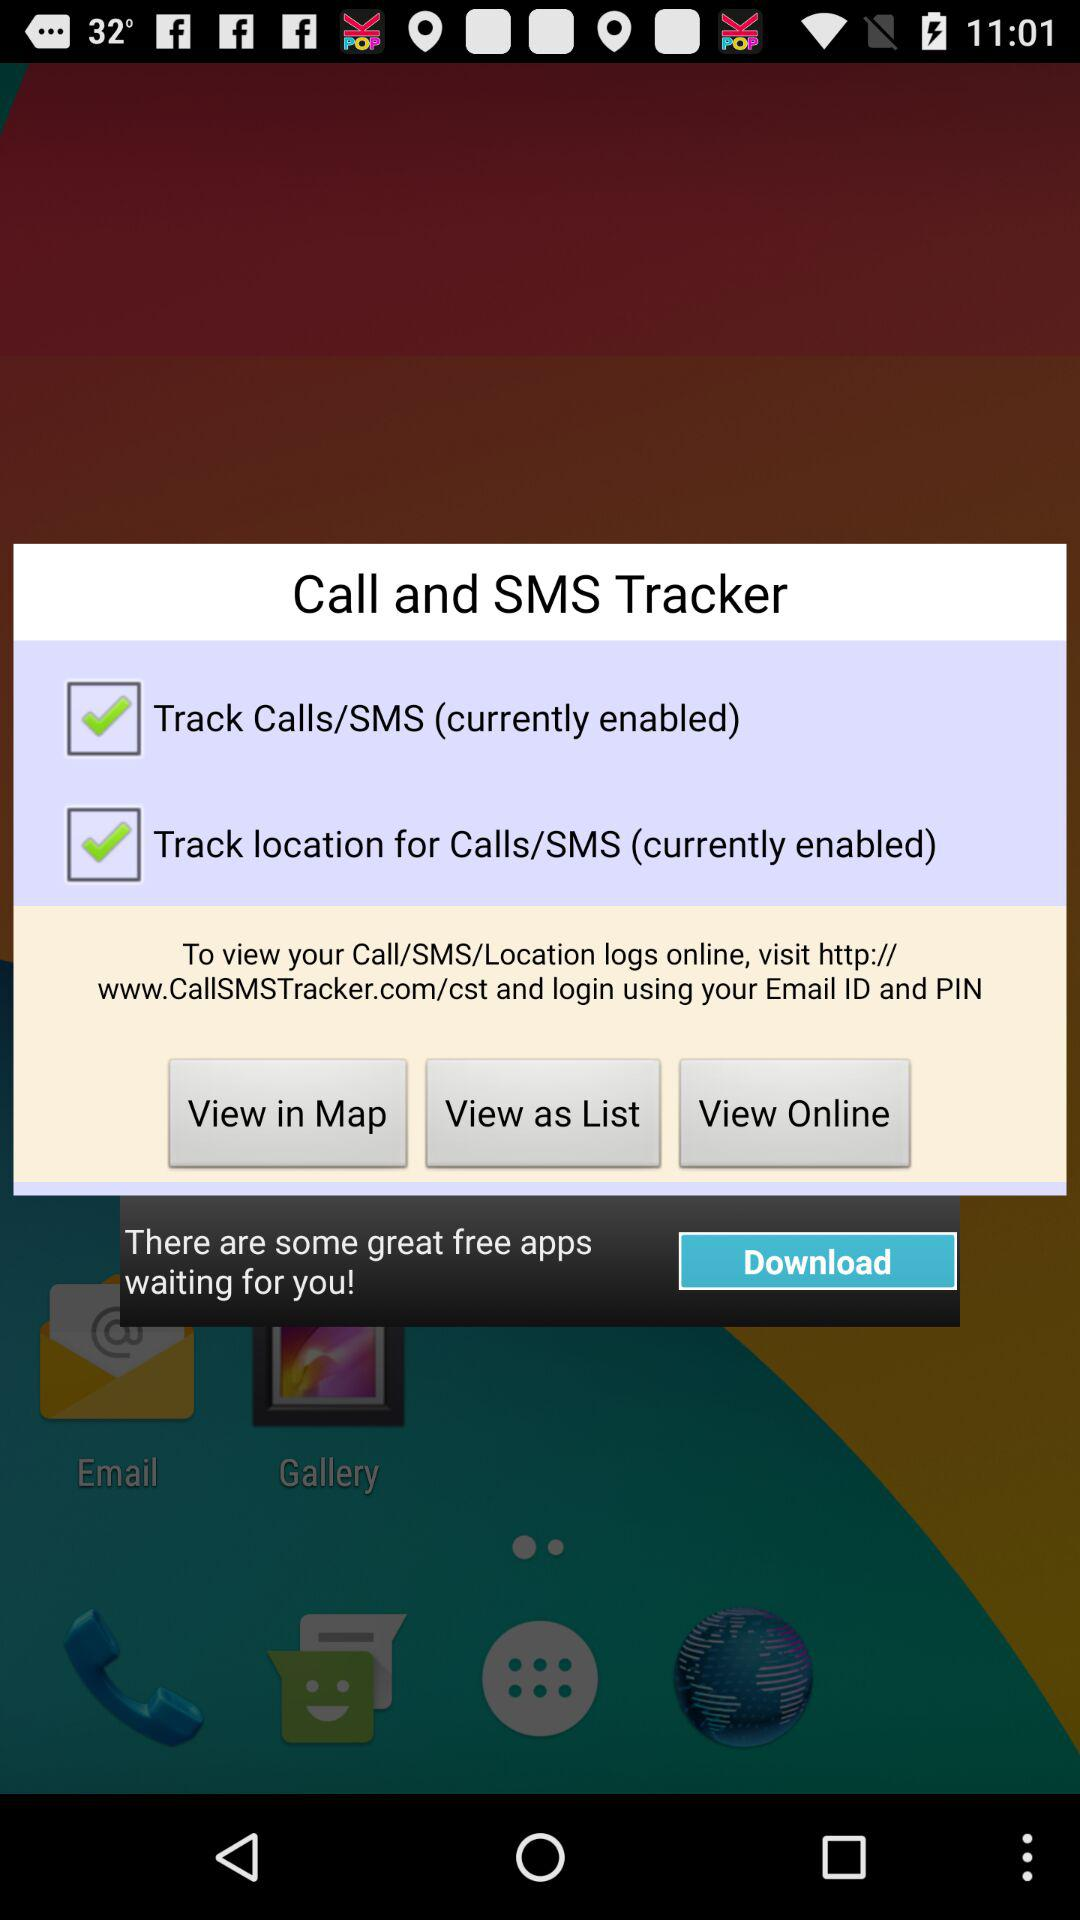How many checkboxes are enabled?
Answer the question using a single word or phrase. 2 